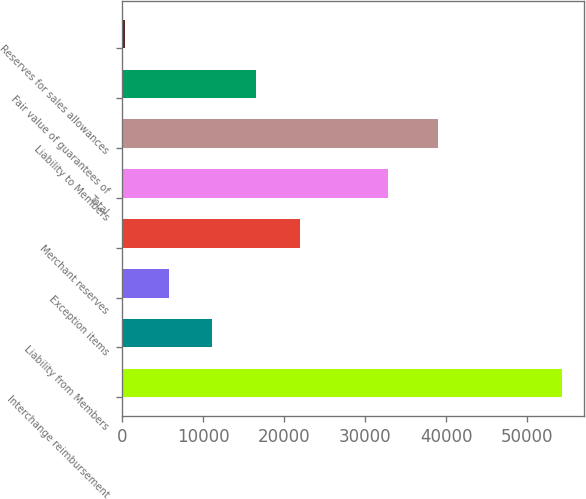Convert chart to OTSL. <chart><loc_0><loc_0><loc_500><loc_500><bar_chart><fcel>Interchange reimbursement<fcel>Liability from Members<fcel>Exception items<fcel>Merchant reserves<fcel>Total<fcel>Liability to Members<fcel>Fair value of guarantees of<fcel>Reserves for sales allowances<nl><fcel>54279<fcel>11118.2<fcel>5723.1<fcel>21908.4<fcel>32853<fcel>38986<fcel>16513.3<fcel>328<nl></chart> 